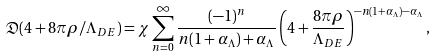Convert formula to latex. <formula><loc_0><loc_0><loc_500><loc_500>\mathfrak { D } ( 4 + 8 \pi \rho / \Lambda _ { D E } ) = \chi \sum _ { n = 0 } ^ { \infty } \frac { ( - 1 ) ^ { n } } { n ( 1 + { \alpha _ { \Lambda } } ) + { \alpha _ { \Lambda } } } \left ( 4 + \frac { 8 \pi \rho } { \Lambda _ { D E } } \right ) ^ { - n ( 1 + { \alpha _ { \Lambda } } ) - { \alpha _ { \Lambda } } } ,</formula> 